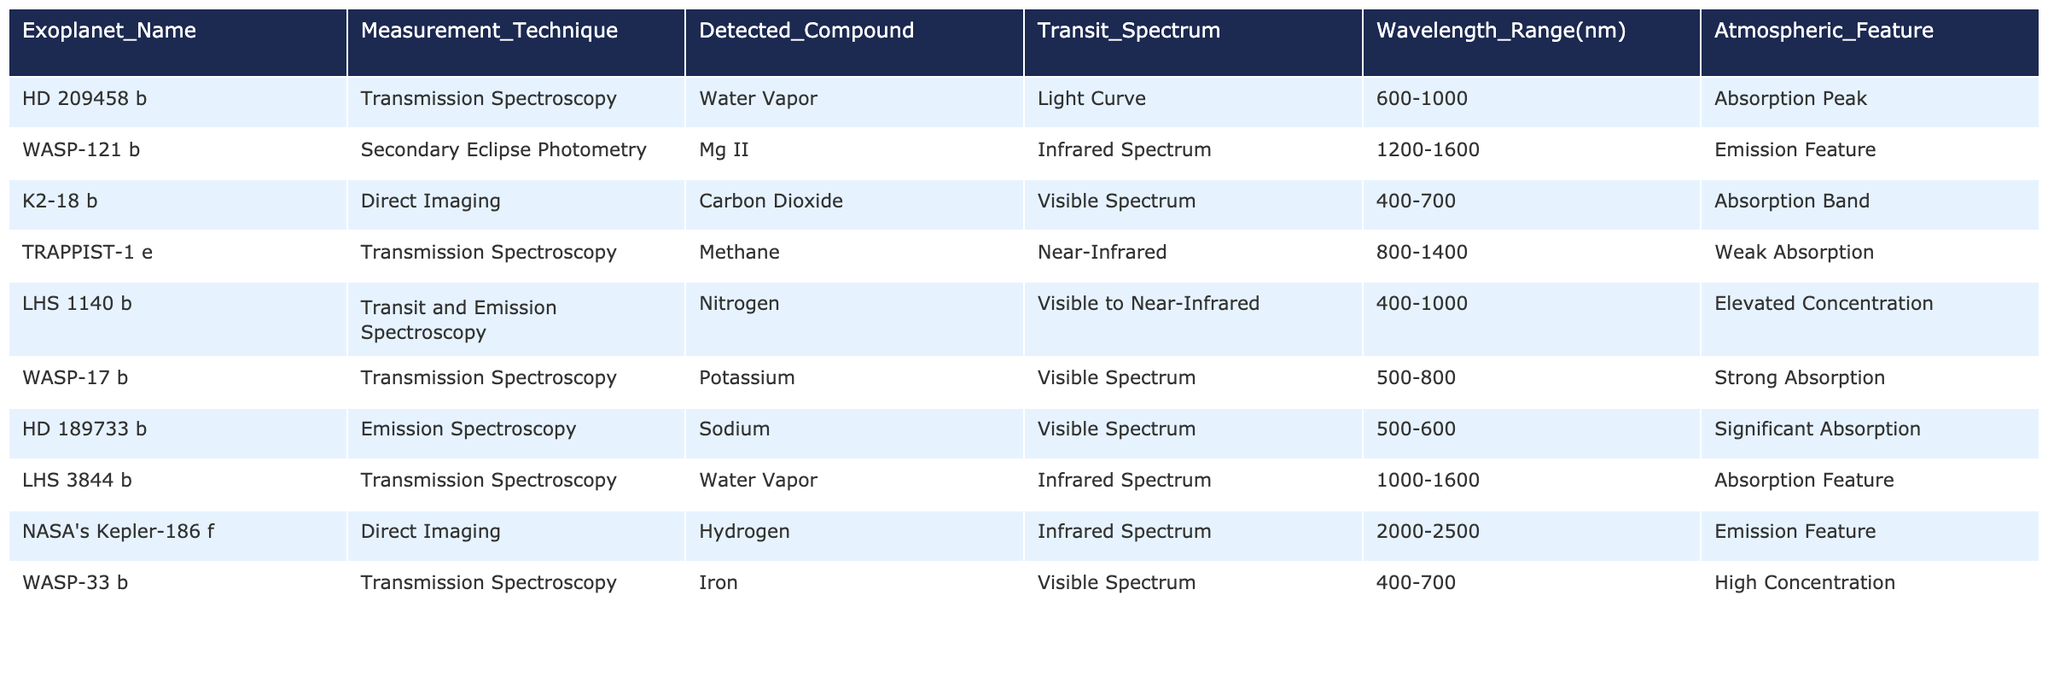What exoplanet has the highest detected atmospheric feature? Among the atmospheric features, the "High Concentration" of Iron can be found in WASP-33 b, which stands out when comparing all the atmospheric features listed.
Answer: WASP-33 b Which measurement technique was used to detect Methane in exoplanet atmospheres? The table shows that Methane was detected in the exoplanet TRAPPIST-1 e using Transmission Spectroscopy.
Answer: Transmission Spectroscopy Are any detected compounds common across multiple exoplanets? Water Vapor appears in the atmospheres of two exoplanets: HD 209458 b and LHS 3844 b, indicating it is a common detected compound.
Answer: Yes What is the wavelength range used for the Secondary Eclipse Photometry technique? The table specifies that the wavelength range for this technique detecting Mg II in the exoplanet WASP-121 b is from 1200 to 1600 nm.
Answer: 1200-1600 nm How many exoplanets utilize Direct Imaging for atmospheric measurement? The table lists two exoplanets, K2-18 b and NASA's Kepler-186 f, that use Direct Imaging to detect atmospheric compounds.
Answer: 2 Is there any exoplanet that shows an absorption peak in its atmospheric feature? Yes, HD 209458 b shows an absorption peak for Water Vapor, confirming that it indeed displays this atmospheric characteristic.
Answer: Yes What is the combined range of wavelengths for the Transmission Spectroscopy technique across all listed exoplanets? The Transmission Spectroscopy technique is used across several ranges: 600-1000 nm, 800-1400 nm, 400-1000 nm, 500-800 nm, and 500-600 nm. The minimum range is 400 nm, and the maximum is 1400 nm, showing a wide range for this technique.
Answer: 400-1400 nm Which atmospheric feature is detected for the exoplanet LHS 1140 b? The exoplanet LHS 1140 b has an elevated concentration of Nitrogen, as indicated by the atmospheric feature listed in the table.
Answer: Elevated Concentration Can we conclude that water vapor was detected in exoplanets with noticeable atmospheric features? Yes, both HD 209458 b and LHS 3844 b, which detected Water Vapor, exhibit significant atmospheric features (Absorption Peak and Absorption Feature respectively).
Answer: Yes What is the unique detection observed in NASA's Kepler-186 f? In NASA's Kepler-186 f, Hydrogen was detected using the Direct Imaging technique, and the atmospheric feature present is an Emission Feature, making it a unique observation.
Answer: Emission Feature 